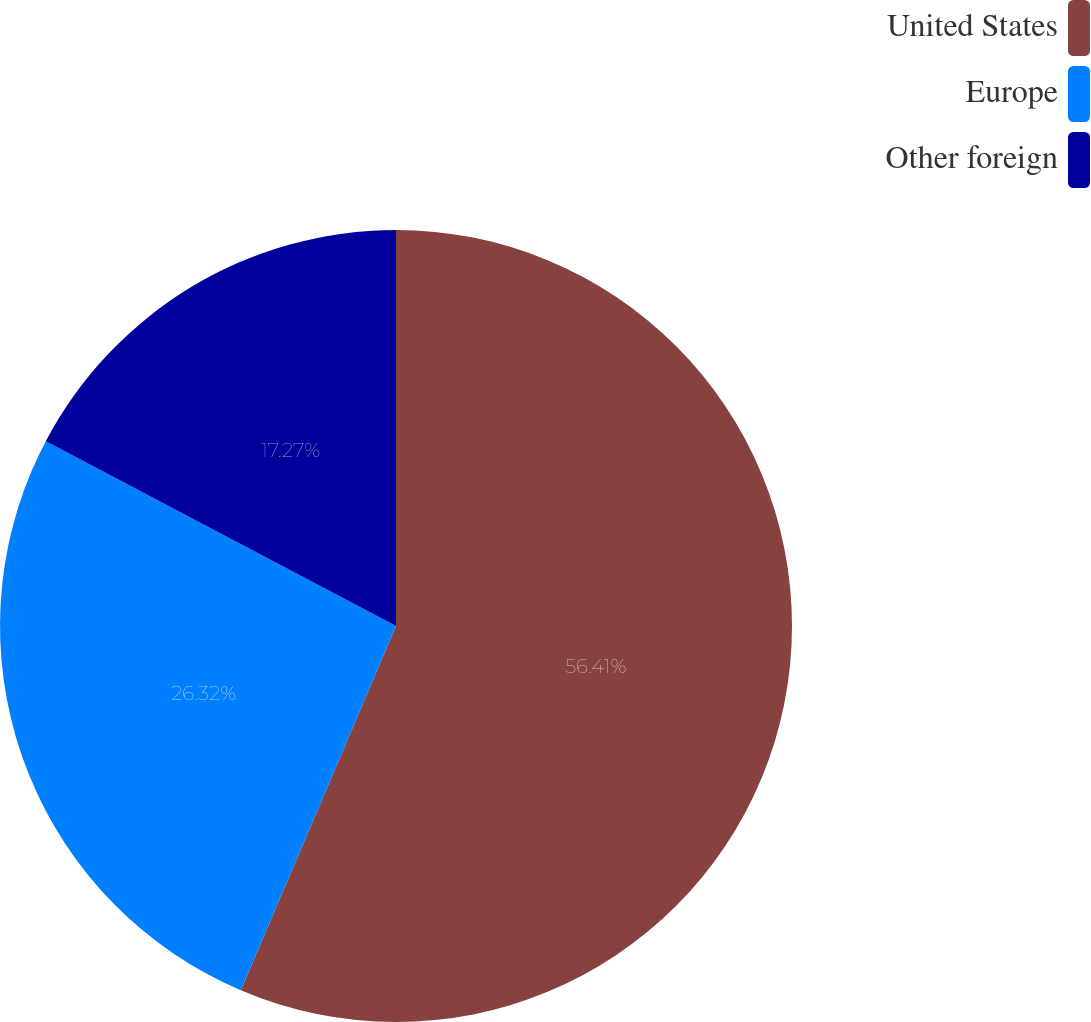Convert chart to OTSL. <chart><loc_0><loc_0><loc_500><loc_500><pie_chart><fcel>United States<fcel>Europe<fcel>Other foreign<nl><fcel>56.41%<fcel>26.32%<fcel>17.27%<nl></chart> 